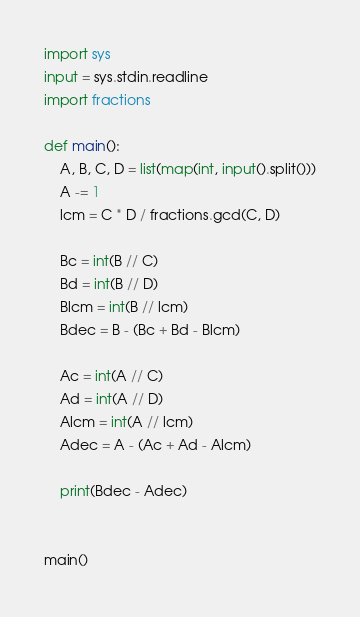Convert code to text. <code><loc_0><loc_0><loc_500><loc_500><_Python_>import sys
input = sys.stdin.readline
import fractions

def main():
    A, B, C, D = list(map(int, input().split()))
    A -= 1
    lcm = C * D / fractions.gcd(C, D)

    Bc = int(B // C)
    Bd = int(B // D)
    Blcm = int(B // lcm)
    Bdec = B - (Bc + Bd - Blcm)

    Ac = int(A // C)
    Ad = int(A // D)
    Alcm = int(A // lcm)
    Adec = A - (Ac + Ad - Alcm)

    print(Bdec - Adec)


main()</code> 